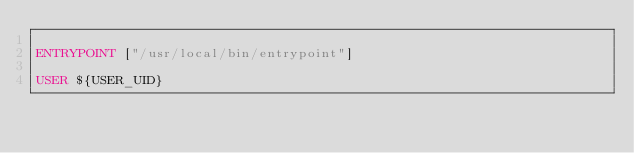<code> <loc_0><loc_0><loc_500><loc_500><_Dockerfile_>
ENTRYPOINT ["/usr/local/bin/entrypoint"]

USER ${USER_UID}
</code> 